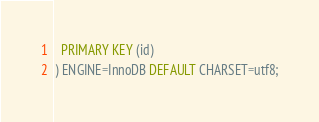<code> <loc_0><loc_0><loc_500><loc_500><_SQL_>  PRIMARY KEY (id)
) ENGINE=InnoDB DEFAULT CHARSET=utf8;</code> 